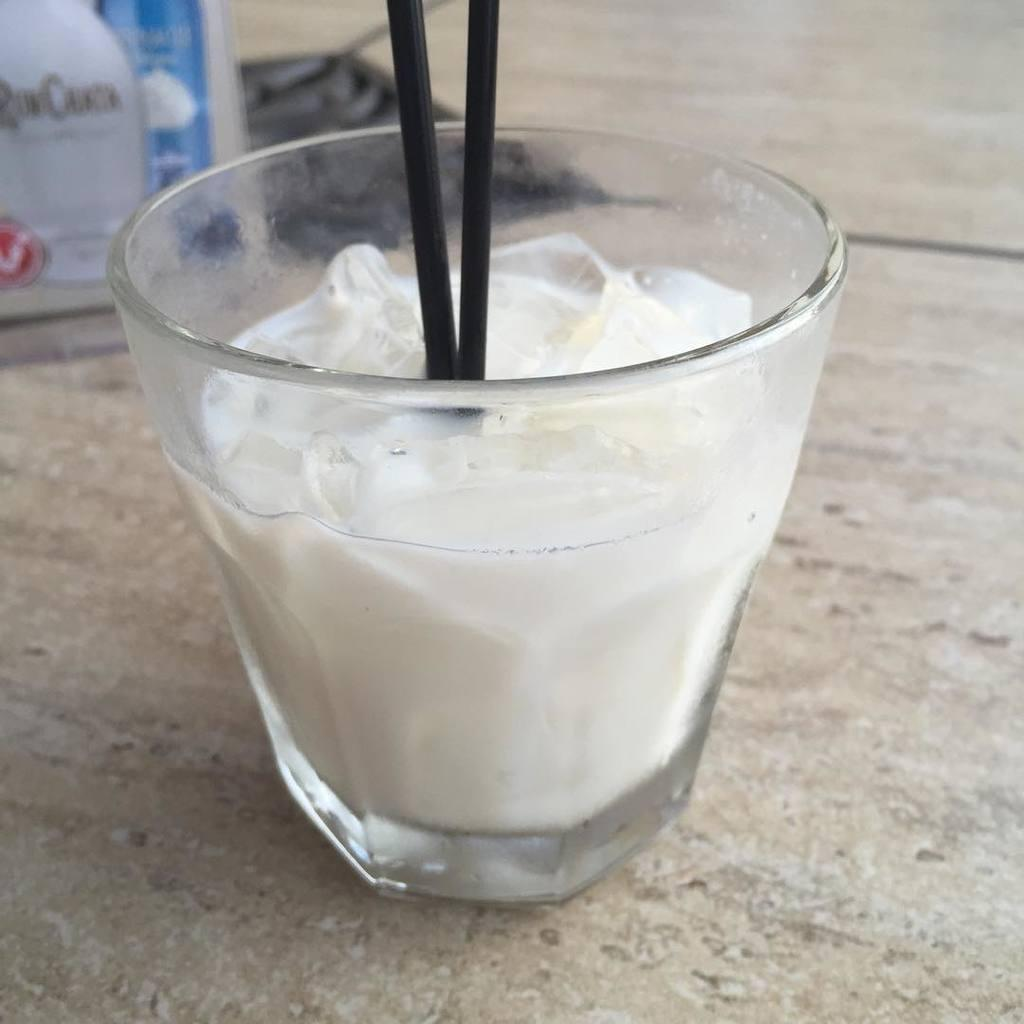What is in the glass that is visible in the image? There is a milkshake in a glass in the image. How might someone consume the milkshake in the image? The milkshake has straws, which can be used for drinking. What can be seen in the background of the image? There are boards and the floor visible in the background of the image. What type of office furniture can be seen in the image? There is no office furniture present in the image. How does the milkshake change its color throughout the day? The milkshake does not change its color throughout the day; it remains the same color as depicted in the image. 